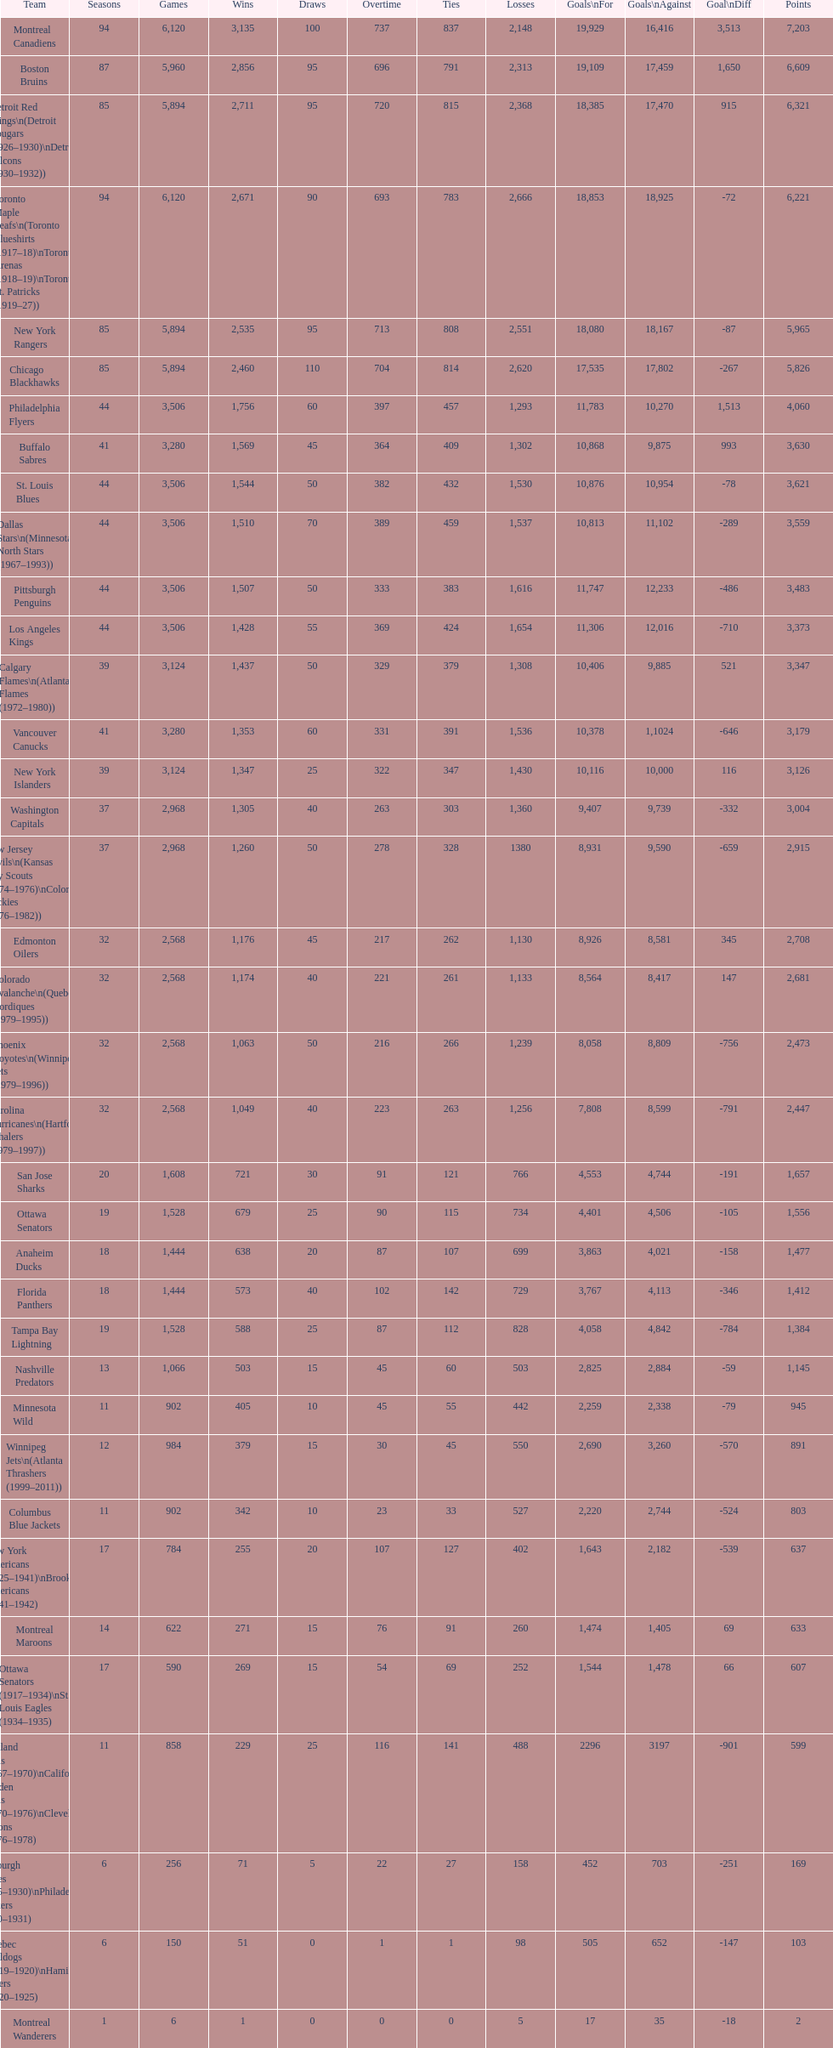Who is at the top of the list? Montreal Canadiens. 